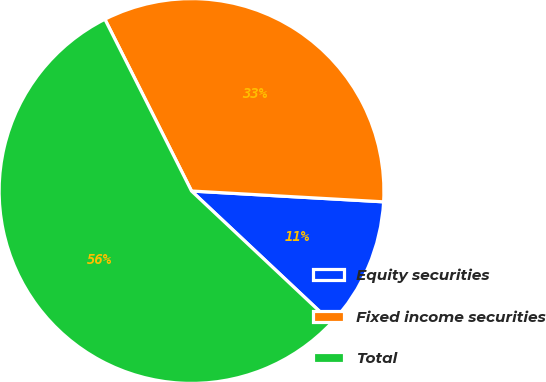Convert chart. <chart><loc_0><loc_0><loc_500><loc_500><pie_chart><fcel>Equity securities<fcel>Fixed income securities<fcel>Total<nl><fcel>11.11%<fcel>33.33%<fcel>55.56%<nl></chart> 